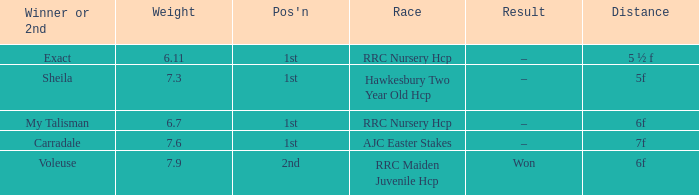What is the largest weight wth a Result of –, and a Distance of 7f? 7.6. 